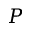Convert formula to latex. <formula><loc_0><loc_0><loc_500><loc_500>P</formula> 